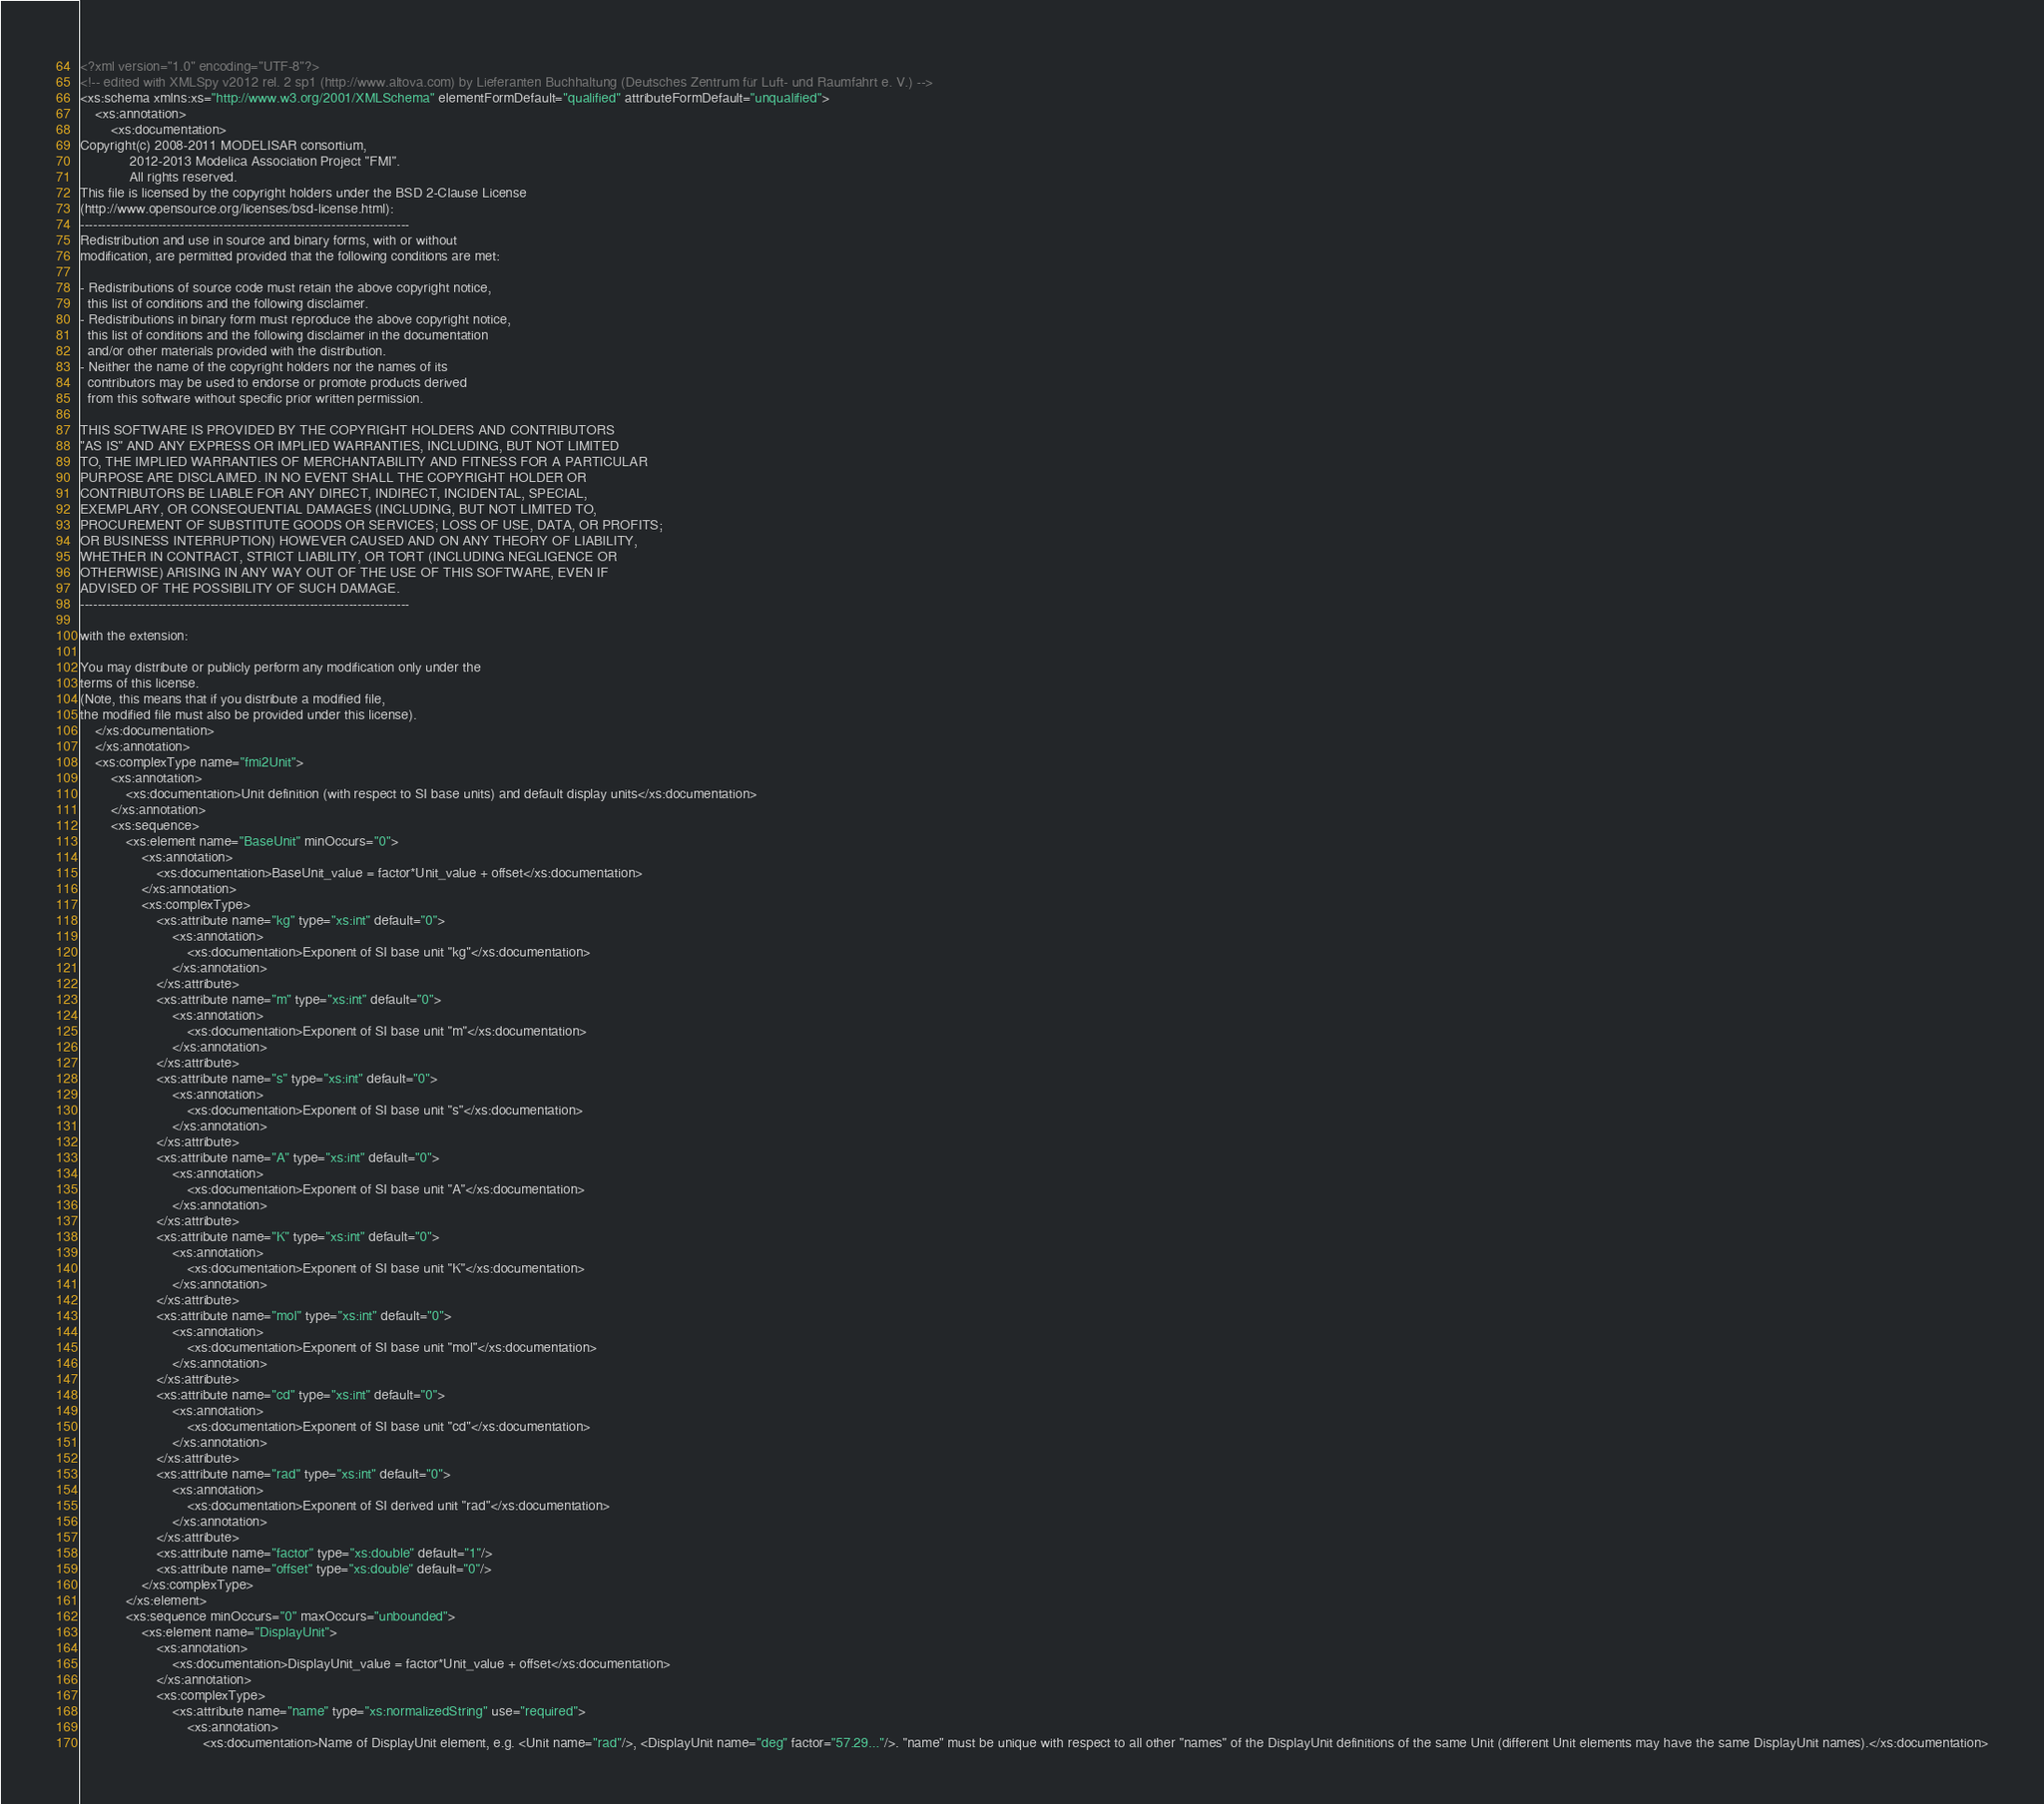Convert code to text. <code><loc_0><loc_0><loc_500><loc_500><_XML_><?xml version="1.0" encoding="UTF-8"?>
<!-- edited with XMLSpy v2012 rel. 2 sp1 (http://www.altova.com) by Lieferanten Buchhaltung (Deutsches Zentrum für Luft- und Raumfahrt e. V.) -->
<xs:schema xmlns:xs="http://www.w3.org/2001/XMLSchema" elementFormDefault="qualified" attributeFormDefault="unqualified">
	<xs:annotation>
		<xs:documentation>
Copyright(c) 2008-2011 MODELISAR consortium,
             2012-2013 Modelica Association Project "FMI".
             All rights reserved.
This file is licensed by the copyright holders under the BSD 2-Clause License
(http://www.opensource.org/licenses/bsd-license.html):
----------------------------------------------------------------------------
Redistribution and use in source and binary forms, with or without
modification, are permitted provided that the following conditions are met:

- Redistributions of source code must retain the above copyright notice,
  this list of conditions and the following disclaimer.
- Redistributions in binary form must reproduce the above copyright notice,
  this list of conditions and the following disclaimer in the documentation
  and/or other materials provided with the distribution.
- Neither the name of the copyright holders nor the names of its
  contributors may be used to endorse or promote products derived
  from this software without specific prior written permission.

THIS SOFTWARE IS PROVIDED BY THE COPYRIGHT HOLDERS AND CONTRIBUTORS
"AS IS" AND ANY EXPRESS OR IMPLIED WARRANTIES, INCLUDING, BUT NOT LIMITED
TO, THE IMPLIED WARRANTIES OF MERCHANTABILITY AND FITNESS FOR A PARTICULAR
PURPOSE ARE DISCLAIMED. IN NO EVENT SHALL THE COPYRIGHT HOLDER OR
CONTRIBUTORS BE LIABLE FOR ANY DIRECT, INDIRECT, INCIDENTAL, SPECIAL,
EXEMPLARY, OR CONSEQUENTIAL DAMAGES (INCLUDING, BUT NOT LIMITED TO,
PROCUREMENT OF SUBSTITUTE GOODS OR SERVICES; LOSS OF USE, DATA, OR PROFITS;
OR BUSINESS INTERRUPTION) HOWEVER CAUSED AND ON ANY THEORY OF LIABILITY,
WHETHER IN CONTRACT, STRICT LIABILITY, OR TORT (INCLUDING NEGLIGENCE OR
OTHERWISE) ARISING IN ANY WAY OUT OF THE USE OF THIS SOFTWARE, EVEN IF
ADVISED OF THE POSSIBILITY OF SUCH DAMAGE.
----------------------------------------------------------------------------

with the extension:

You may distribute or publicly perform any modification only under the
terms of this license.
(Note, this means that if you distribute a modified file,
the modified file must also be provided under this license).
    </xs:documentation>
	</xs:annotation>
	<xs:complexType name="fmi2Unit">
		<xs:annotation>
			<xs:documentation>Unit definition (with respect to SI base units) and default display units</xs:documentation>
		</xs:annotation>
		<xs:sequence>
			<xs:element name="BaseUnit" minOccurs="0">
				<xs:annotation>
					<xs:documentation>BaseUnit_value = factor*Unit_value + offset</xs:documentation>
				</xs:annotation>
				<xs:complexType>
					<xs:attribute name="kg" type="xs:int" default="0">
						<xs:annotation>
							<xs:documentation>Exponent of SI base unit "kg"</xs:documentation>
						</xs:annotation>
					</xs:attribute>
					<xs:attribute name="m" type="xs:int" default="0">
						<xs:annotation>
							<xs:documentation>Exponent of SI base unit "m"</xs:documentation>
						</xs:annotation>
					</xs:attribute>
					<xs:attribute name="s" type="xs:int" default="0">
						<xs:annotation>
							<xs:documentation>Exponent of SI base unit "s"</xs:documentation>
						</xs:annotation>
					</xs:attribute>
					<xs:attribute name="A" type="xs:int" default="0">
						<xs:annotation>
							<xs:documentation>Exponent of SI base unit "A"</xs:documentation>
						</xs:annotation>
					</xs:attribute>
					<xs:attribute name="K" type="xs:int" default="0">
						<xs:annotation>
							<xs:documentation>Exponent of SI base unit "K"</xs:documentation>
						</xs:annotation>
					</xs:attribute>
					<xs:attribute name="mol" type="xs:int" default="0">
						<xs:annotation>
							<xs:documentation>Exponent of SI base unit "mol"</xs:documentation>
						</xs:annotation>
					</xs:attribute>
					<xs:attribute name="cd" type="xs:int" default="0">
						<xs:annotation>
							<xs:documentation>Exponent of SI base unit "cd"</xs:documentation>
						</xs:annotation>
					</xs:attribute>
					<xs:attribute name="rad" type="xs:int" default="0">
						<xs:annotation>
							<xs:documentation>Exponent of SI derived unit "rad"</xs:documentation>
						</xs:annotation>
					</xs:attribute>
					<xs:attribute name="factor" type="xs:double" default="1"/>
					<xs:attribute name="offset" type="xs:double" default="0"/>
				</xs:complexType>
			</xs:element>
			<xs:sequence minOccurs="0" maxOccurs="unbounded">
				<xs:element name="DisplayUnit">
					<xs:annotation>
						<xs:documentation>DisplayUnit_value = factor*Unit_value + offset</xs:documentation>
					</xs:annotation>
					<xs:complexType>
						<xs:attribute name="name" type="xs:normalizedString" use="required">
							<xs:annotation>
								<xs:documentation>Name of DisplayUnit element, e.g. <Unit name="rad"/>, <DisplayUnit name="deg" factor="57.29..."/>. "name" must be unique with respect to all other "names" of the DisplayUnit definitions of the same Unit (different Unit elements may have the same DisplayUnit names).</xs:documentation></code> 